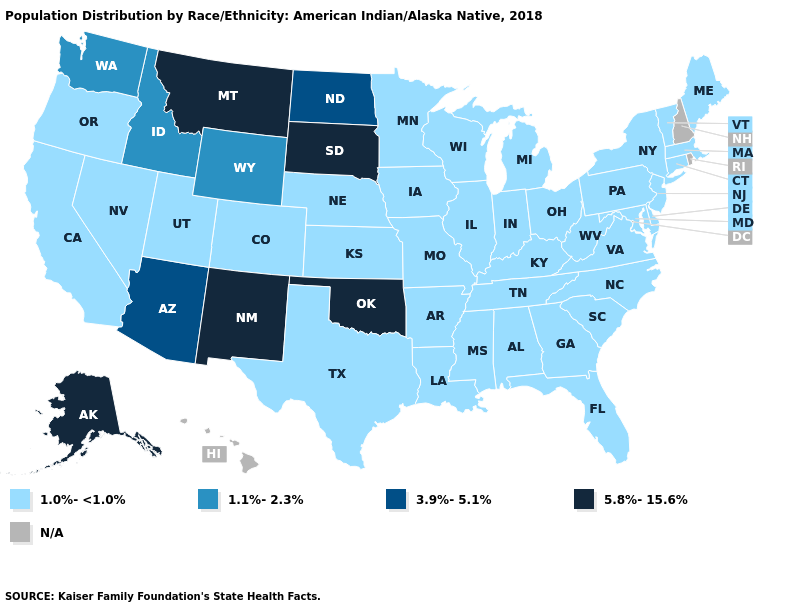Does Michigan have the highest value in the MidWest?
Give a very brief answer. No. What is the highest value in the MidWest ?
Answer briefly. 5.8%-15.6%. Name the states that have a value in the range 1.0%-<1.0%?
Concise answer only. Alabama, Arkansas, California, Colorado, Connecticut, Delaware, Florida, Georgia, Illinois, Indiana, Iowa, Kansas, Kentucky, Louisiana, Maine, Maryland, Massachusetts, Michigan, Minnesota, Mississippi, Missouri, Nebraska, Nevada, New Jersey, New York, North Carolina, Ohio, Oregon, Pennsylvania, South Carolina, Tennessee, Texas, Utah, Vermont, Virginia, West Virginia, Wisconsin. What is the value of West Virginia?
Write a very short answer. 1.0%-<1.0%. Which states have the lowest value in the MidWest?
Keep it brief. Illinois, Indiana, Iowa, Kansas, Michigan, Minnesota, Missouri, Nebraska, Ohio, Wisconsin. Does the first symbol in the legend represent the smallest category?
Answer briefly. Yes. Does North Dakota have the lowest value in the USA?
Quick response, please. No. Which states have the lowest value in the Northeast?
Keep it brief. Connecticut, Maine, Massachusetts, New Jersey, New York, Pennsylvania, Vermont. What is the highest value in the Northeast ?
Write a very short answer. 1.0%-<1.0%. What is the highest value in the MidWest ?
Short answer required. 5.8%-15.6%. Name the states that have a value in the range 1.1%-2.3%?
Write a very short answer. Idaho, Washington, Wyoming. 